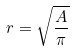<formula> <loc_0><loc_0><loc_500><loc_500>r = \sqrt { \frac { A } { \pi } }</formula> 